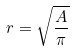<formula> <loc_0><loc_0><loc_500><loc_500>r = \sqrt { \frac { A } { \pi } }</formula> 